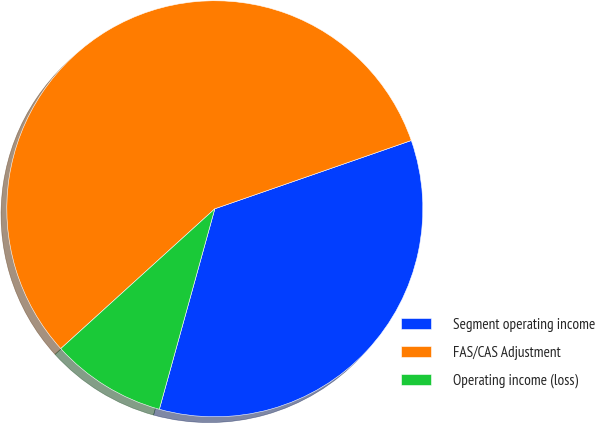Convert chart to OTSL. <chart><loc_0><loc_0><loc_500><loc_500><pie_chart><fcel>Segment operating income<fcel>FAS/CAS Adjustment<fcel>Operating income (loss)<nl><fcel>34.62%<fcel>56.41%<fcel>8.97%<nl></chart> 